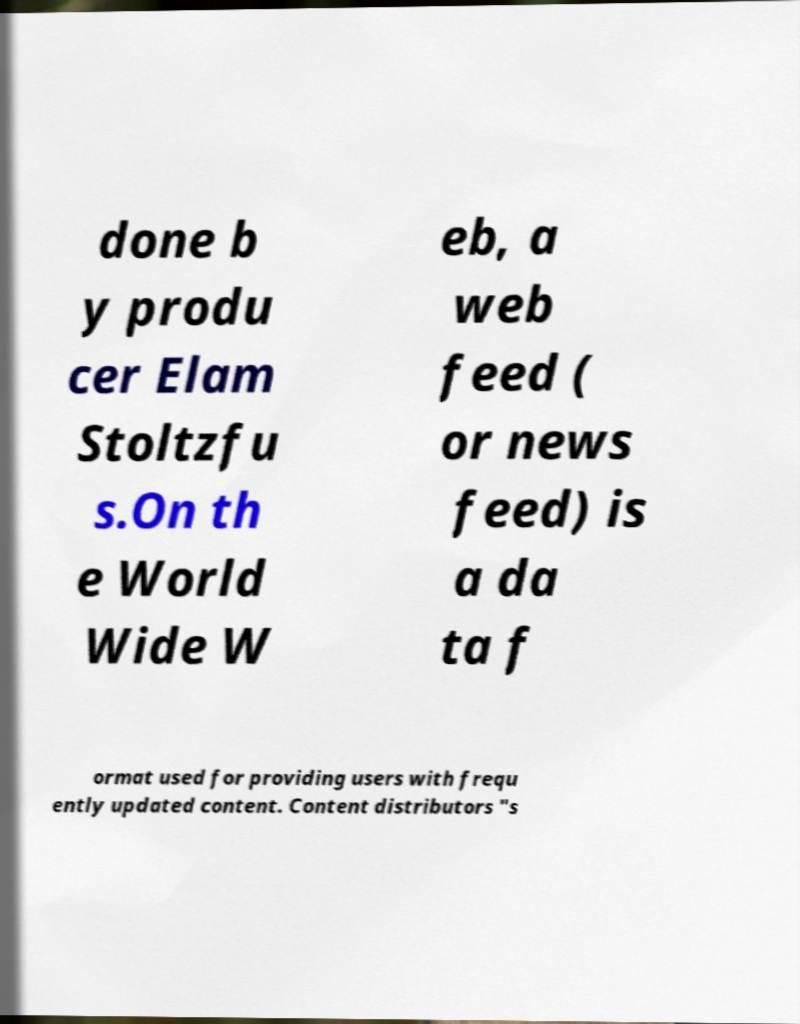For documentation purposes, I need the text within this image transcribed. Could you provide that? done b y produ cer Elam Stoltzfu s.On th e World Wide W eb, a web feed ( or news feed) is a da ta f ormat used for providing users with frequ ently updated content. Content distributors "s 